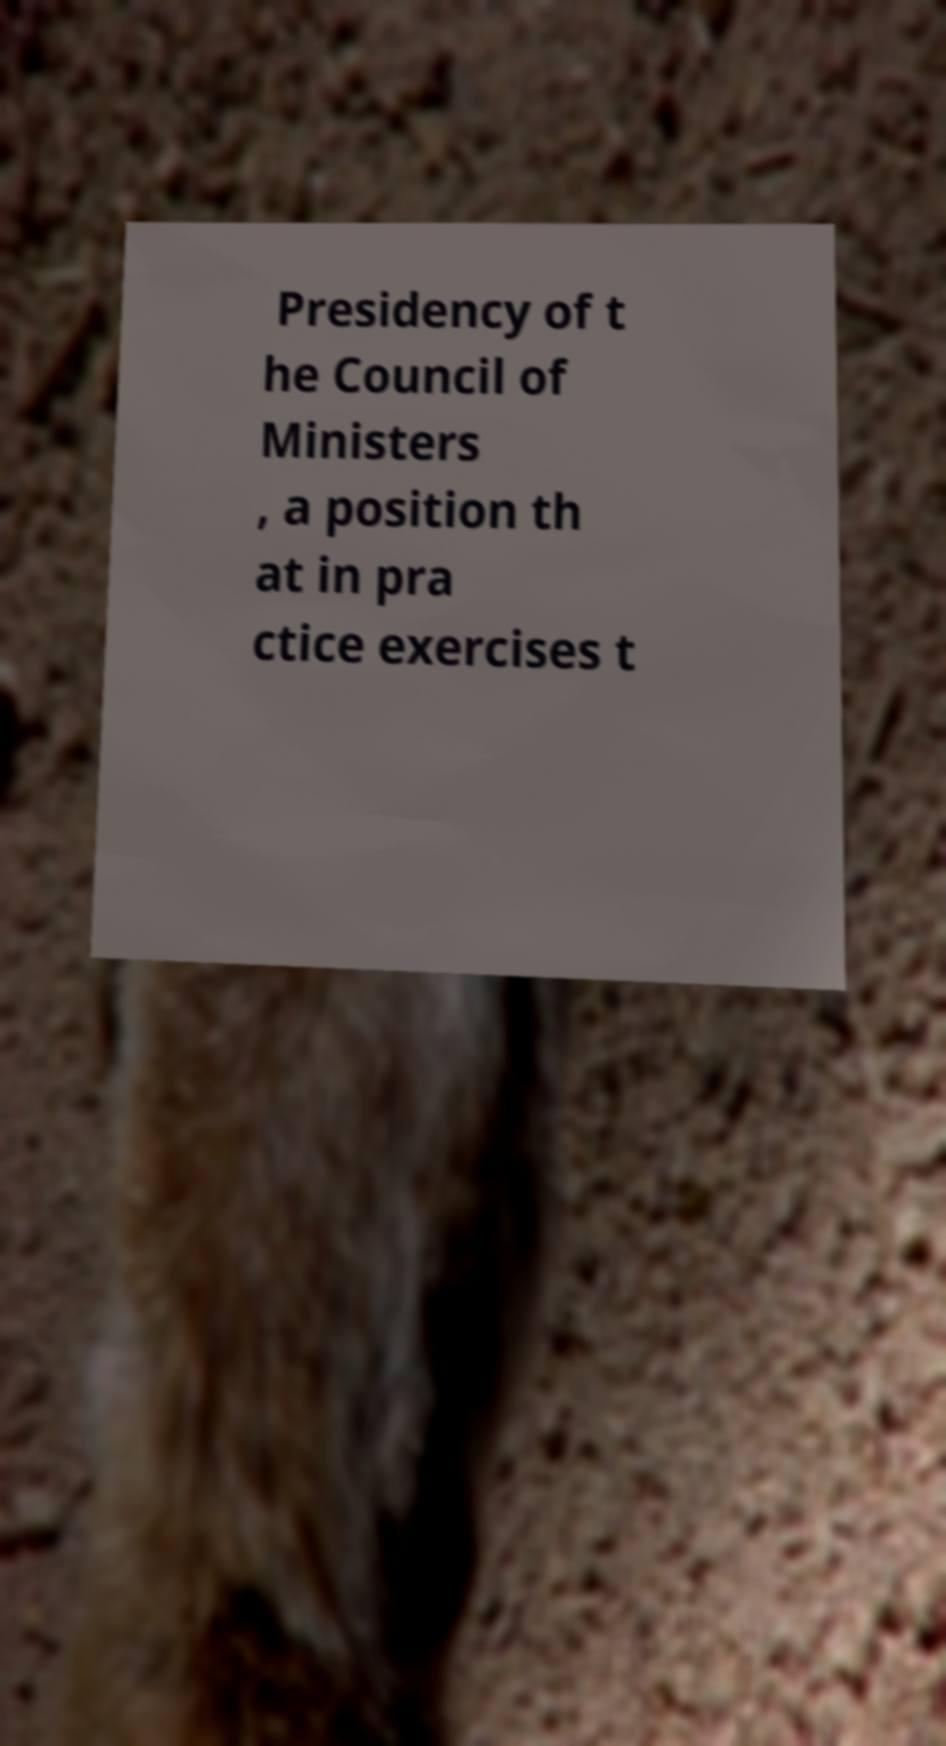Please identify and transcribe the text found in this image. Presidency of t he Council of Ministers , a position th at in pra ctice exercises t 